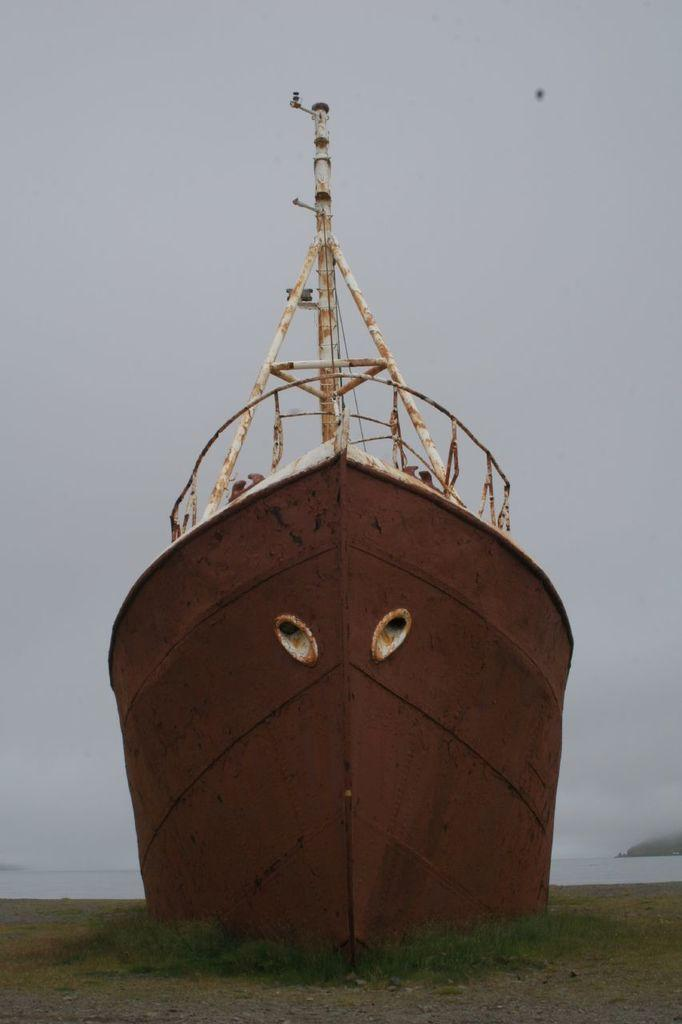What is the main subject of the image? The main subject of the image is a boat. What can be seen in the background of the image? The sky is visible in the background of the image. Where is the zoo located in the image? There is no zoo present in the image; it features a boat and the sky. What type of structure can be seen supporting the boat in the image? There is no structure supporting the boat visible in the image. 